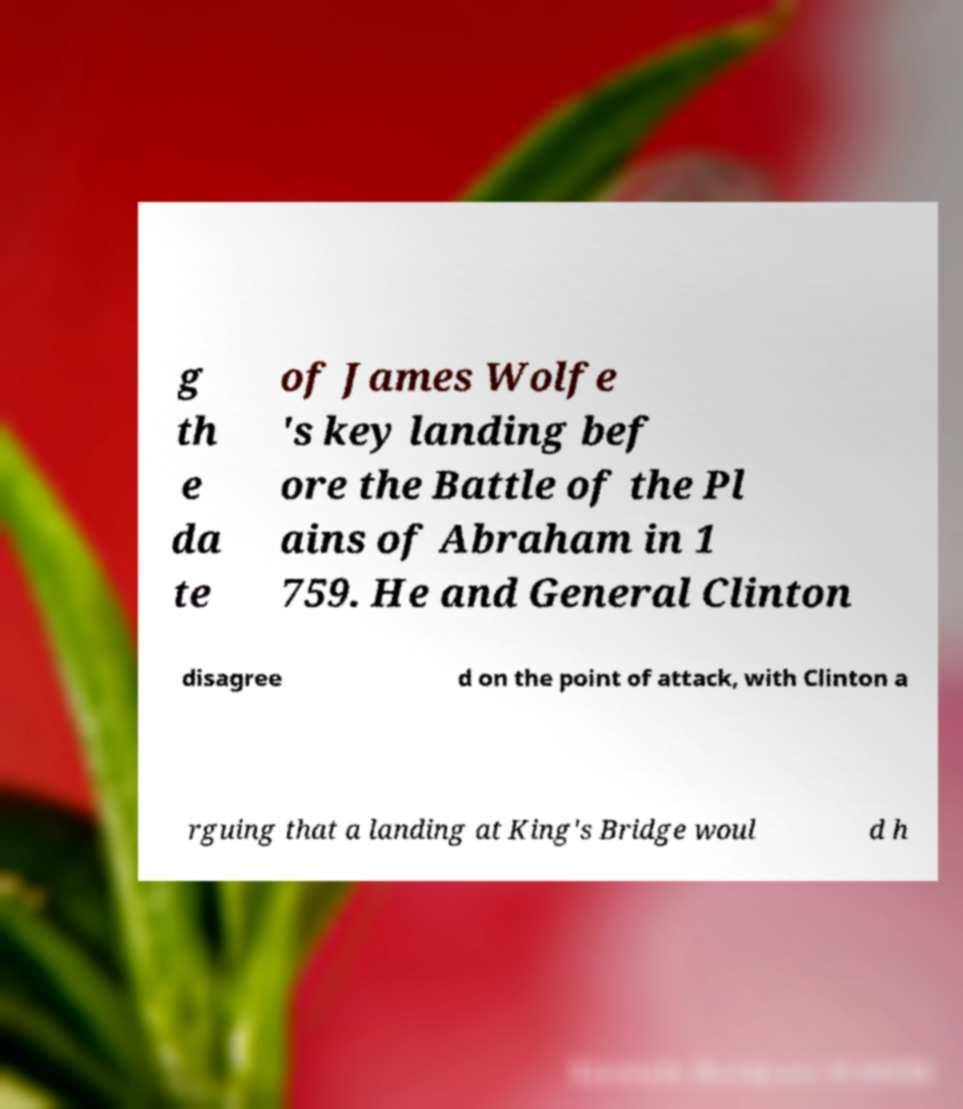Could you extract and type out the text from this image? g th e da te of James Wolfe 's key landing bef ore the Battle of the Pl ains of Abraham in 1 759. He and General Clinton disagree d on the point of attack, with Clinton a rguing that a landing at King's Bridge woul d h 